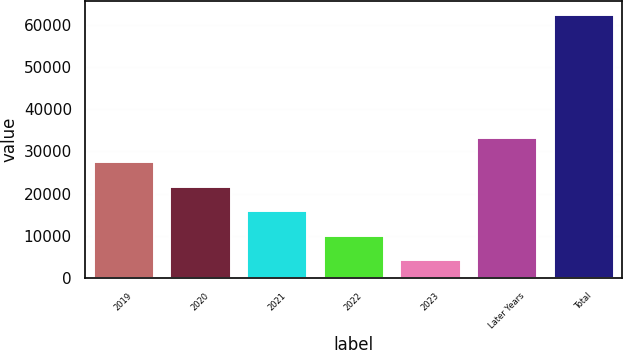Convert chart to OTSL. <chart><loc_0><loc_0><loc_500><loc_500><bar_chart><fcel>2019<fcel>2020<fcel>2021<fcel>2022<fcel>2023<fcel>Later Years<fcel>Total<nl><fcel>27659.8<fcel>21858.1<fcel>16056.4<fcel>10254.7<fcel>4453<fcel>33461.5<fcel>62470<nl></chart> 